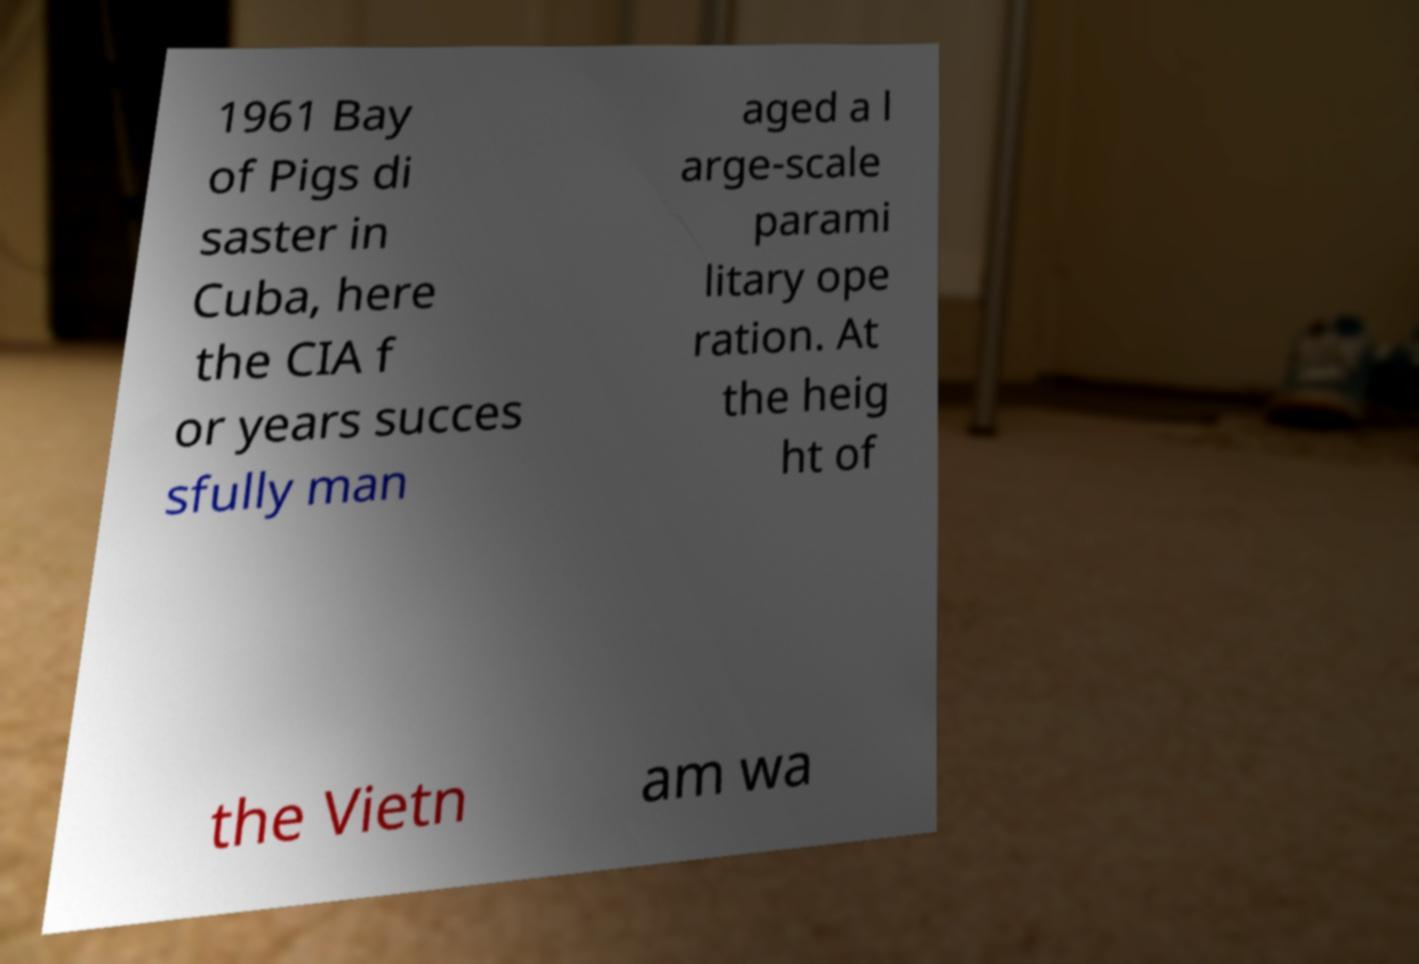Could you extract and type out the text from this image? 1961 Bay of Pigs di saster in Cuba, here the CIA f or years succes sfully man aged a l arge-scale parami litary ope ration. At the heig ht of the Vietn am wa 